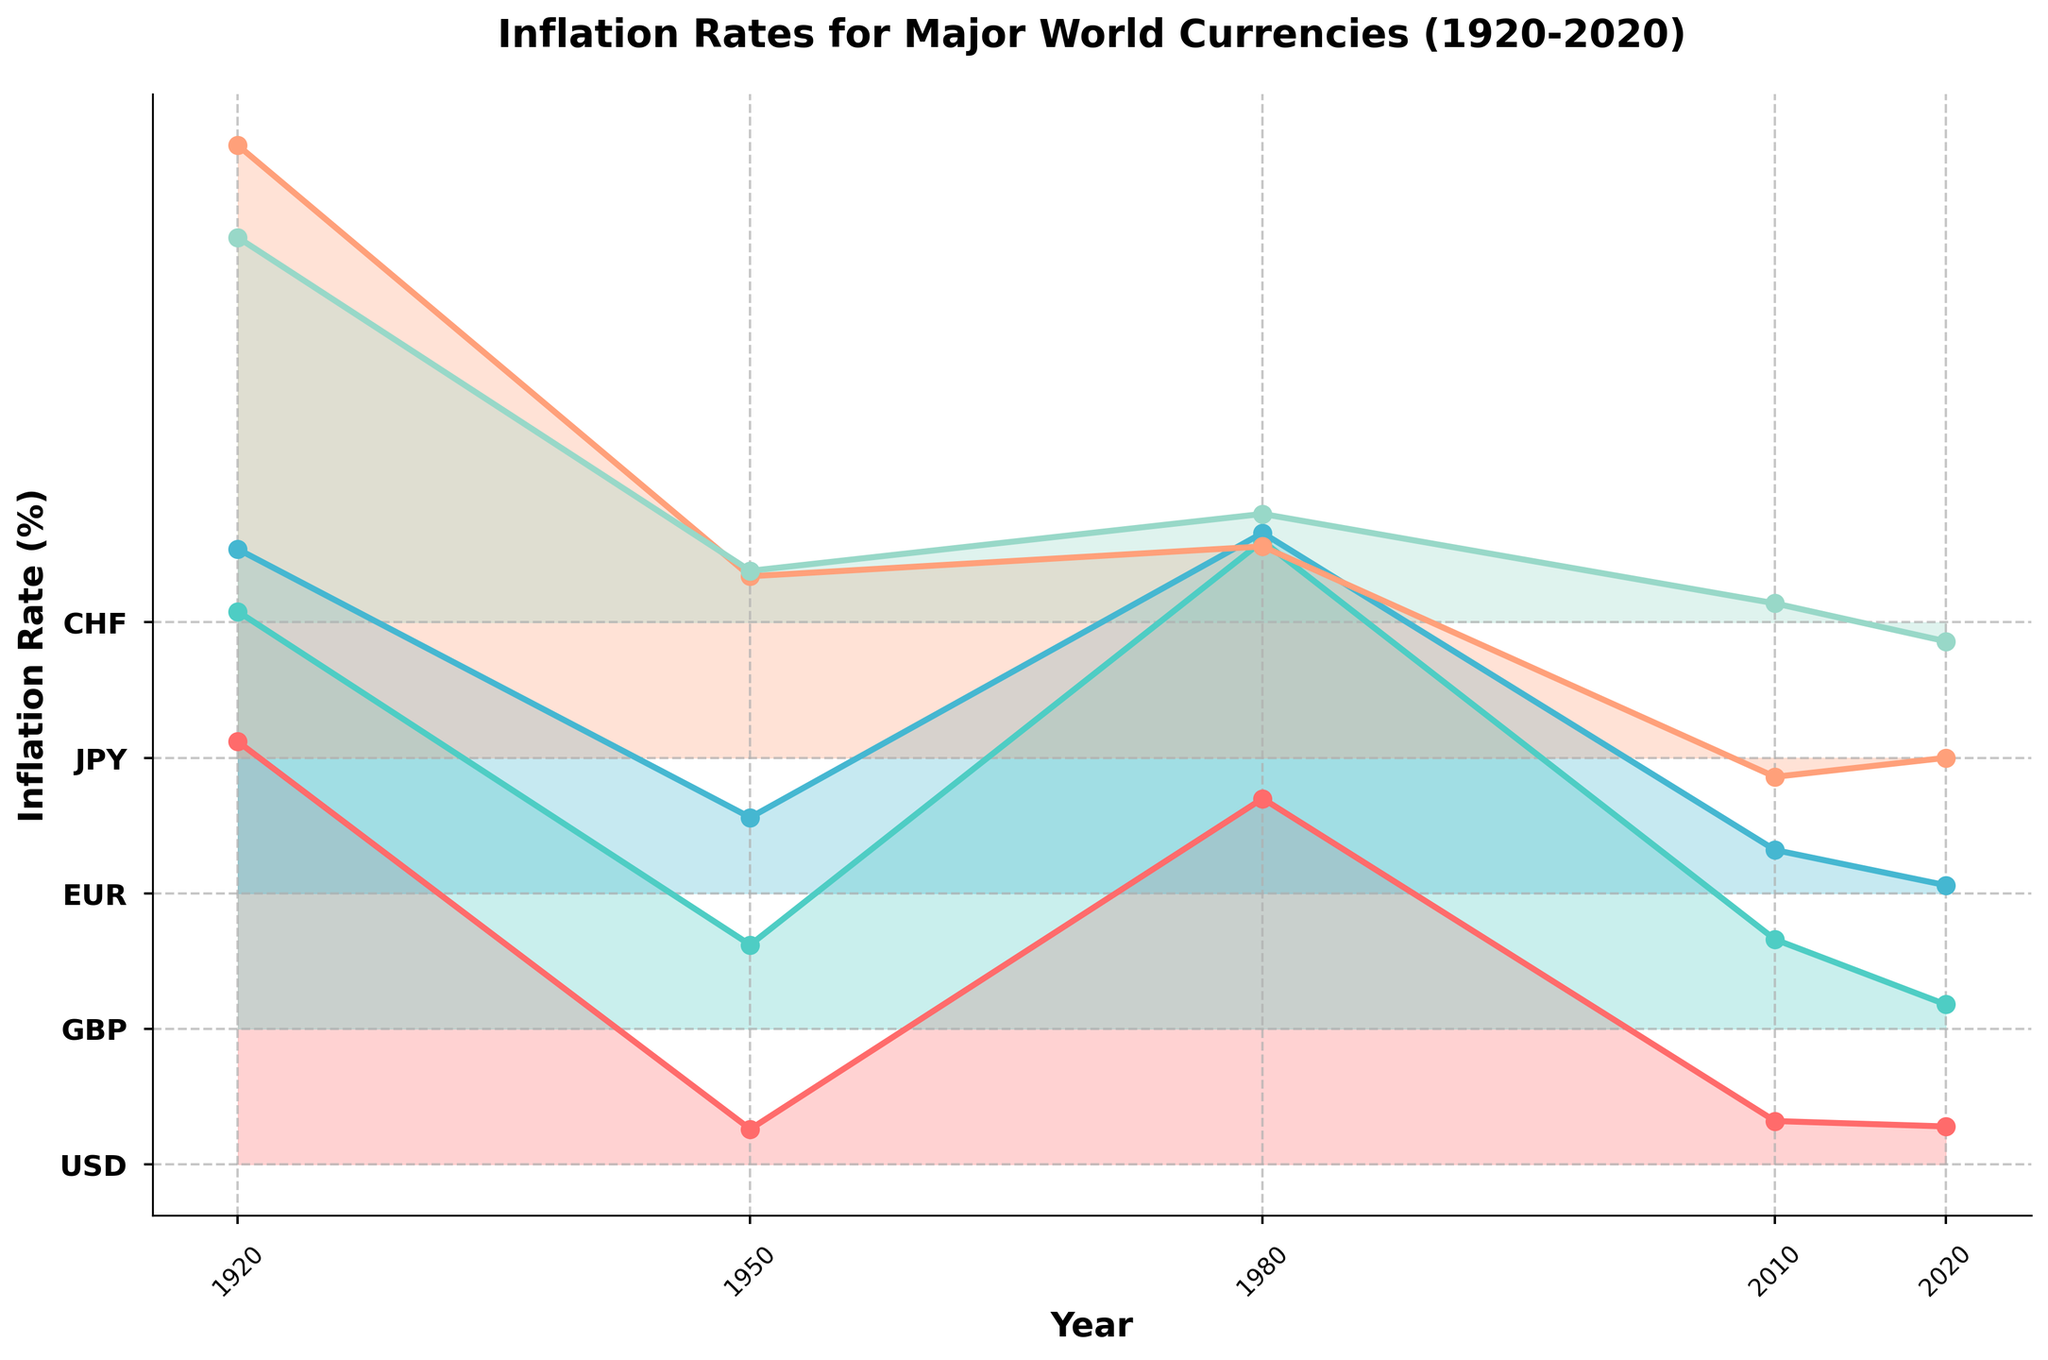What is the title of the figure? The title is usually located at the top of the figure and is typically larger and bolder than the other text. In this figure, the title is "Inflation Rates for Major World Currencies (1920-2020)".
Answer: Inflation Rates for Major World Currencies (1920-2020) Which currency has the highest inflation rate in 1980? To determine this, locate 1980 on the x-axis and check the corresponding y-values for each currency. The highest y-value corresponds to the GBP.
Answer: GBP How many years are displayed on the x-axis? Count the tick marks or labels on the x-axis. The years displayed are 1920, 1950, 1980, 2010, and 2020, so there are 5 years in total.
Answer: 5 Which currency shows a decreasing trend in inflation rate from 1980 to 2020? Examine the lines corresponding to each currency from 1980 to 2020. The USD shows a decreasing trend over these years.
Answer: USD What is the y-axis label for the figure? The y-axis label is typically located along the vertical edge of the graph. It reads "Inflation Rate (%)".
Answer: Inflation Rate (%) What is the inflation rate for USD in 1950? Find the USD line, then locate 1950 on the x-axis and check the corresponding y-axis value. The inflation rate for USD in 1950 is approximately 1.3%.
Answer: 1.3% Which currency had a negative inflation rate in 2010? Check the y-values for each currency above the year 2010 on the x-axis. The JPY had a negative inflation rate in 2010.
Answer: JPY Compare the inflation rates of CHF and EUR in 2020. Which is higher and by how much? Locate 2020 on the x-axis and check the y-values of CHF and EUR lines. EUR has a higher inflation rate at 0.3%, while CHF has -0.7%, making the difference 1.0%.
Answer: EUR by 1.0% Did all currencies show an increase in inflation rate from 1920 to 1950? Check the inflation rates for each currency in 1920 and compare them to their values in 1950. All currencies except CHF increased from 1920 to 1950.
Answer: No Which country has experienced periods of deflation? Look for negative values on y-axis for the entire time period. Both JPY and CHF experienced periods of deflation, indicated by y-values falling below zero.
Answer: JPY and CHF 